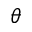Convert formula to latex. <formula><loc_0><loc_0><loc_500><loc_500>\theta</formula> 